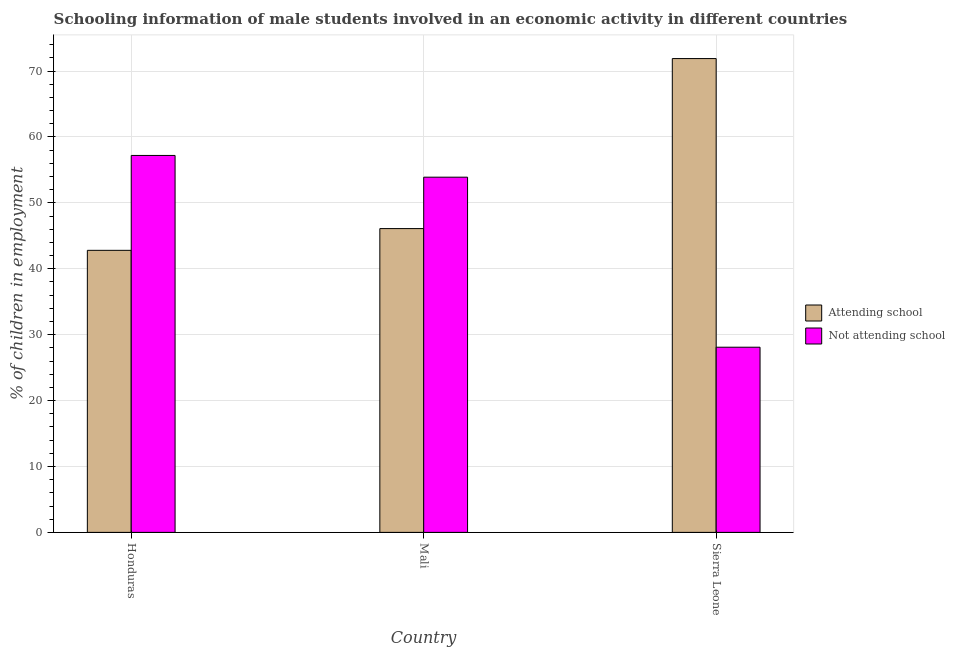Are the number of bars per tick equal to the number of legend labels?
Offer a terse response. Yes. How many bars are there on the 3rd tick from the left?
Offer a terse response. 2. What is the label of the 2nd group of bars from the left?
Provide a short and direct response. Mali. What is the percentage of employed males who are not attending school in Honduras?
Your response must be concise. 57.2. Across all countries, what is the maximum percentage of employed males who are not attending school?
Offer a very short reply. 57.2. Across all countries, what is the minimum percentage of employed males who are not attending school?
Your response must be concise. 28.1. In which country was the percentage of employed males who are attending school maximum?
Offer a very short reply. Sierra Leone. In which country was the percentage of employed males who are not attending school minimum?
Offer a very short reply. Sierra Leone. What is the total percentage of employed males who are not attending school in the graph?
Provide a succinct answer. 139.2. What is the difference between the percentage of employed males who are not attending school in Mali and that in Sierra Leone?
Make the answer very short. 25.8. What is the difference between the percentage of employed males who are attending school in Sierra Leone and the percentage of employed males who are not attending school in Honduras?
Offer a terse response. 14.7. What is the average percentage of employed males who are not attending school per country?
Ensure brevity in your answer.  46.4. What is the difference between the percentage of employed males who are not attending school and percentage of employed males who are attending school in Sierra Leone?
Provide a succinct answer. -43.8. What is the ratio of the percentage of employed males who are attending school in Honduras to that in Mali?
Provide a short and direct response. 0.93. Is the difference between the percentage of employed males who are attending school in Mali and Sierra Leone greater than the difference between the percentage of employed males who are not attending school in Mali and Sierra Leone?
Provide a short and direct response. No. What is the difference between the highest and the second highest percentage of employed males who are attending school?
Provide a succinct answer. 25.8. What is the difference between the highest and the lowest percentage of employed males who are attending school?
Keep it short and to the point. 29.1. Is the sum of the percentage of employed males who are attending school in Honduras and Sierra Leone greater than the maximum percentage of employed males who are not attending school across all countries?
Keep it short and to the point. Yes. What does the 2nd bar from the left in Mali represents?
Keep it short and to the point. Not attending school. What does the 2nd bar from the right in Sierra Leone represents?
Make the answer very short. Attending school. How many bars are there?
Your answer should be compact. 6. What is the difference between two consecutive major ticks on the Y-axis?
Offer a terse response. 10. Are the values on the major ticks of Y-axis written in scientific E-notation?
Make the answer very short. No. Does the graph contain any zero values?
Keep it short and to the point. No. Where does the legend appear in the graph?
Your response must be concise. Center right. How many legend labels are there?
Keep it short and to the point. 2. How are the legend labels stacked?
Make the answer very short. Vertical. What is the title of the graph?
Your answer should be compact. Schooling information of male students involved in an economic activity in different countries. Does "Female labourers" appear as one of the legend labels in the graph?
Your answer should be very brief. No. What is the label or title of the Y-axis?
Give a very brief answer. % of children in employment. What is the % of children in employment of Attending school in Honduras?
Provide a short and direct response. 42.8. What is the % of children in employment of Not attending school in Honduras?
Ensure brevity in your answer.  57.2. What is the % of children in employment of Attending school in Mali?
Provide a short and direct response. 46.1. What is the % of children in employment of Not attending school in Mali?
Provide a short and direct response. 53.9. What is the % of children in employment in Attending school in Sierra Leone?
Ensure brevity in your answer.  71.9. What is the % of children in employment in Not attending school in Sierra Leone?
Your response must be concise. 28.1. Across all countries, what is the maximum % of children in employment in Attending school?
Your answer should be very brief. 71.9. Across all countries, what is the maximum % of children in employment of Not attending school?
Your response must be concise. 57.2. Across all countries, what is the minimum % of children in employment of Attending school?
Your response must be concise. 42.8. Across all countries, what is the minimum % of children in employment of Not attending school?
Provide a short and direct response. 28.1. What is the total % of children in employment of Attending school in the graph?
Ensure brevity in your answer.  160.8. What is the total % of children in employment in Not attending school in the graph?
Your answer should be very brief. 139.2. What is the difference between the % of children in employment of Not attending school in Honduras and that in Mali?
Give a very brief answer. 3.3. What is the difference between the % of children in employment in Attending school in Honduras and that in Sierra Leone?
Provide a succinct answer. -29.1. What is the difference between the % of children in employment in Not attending school in Honduras and that in Sierra Leone?
Your response must be concise. 29.1. What is the difference between the % of children in employment in Attending school in Mali and that in Sierra Leone?
Provide a short and direct response. -25.8. What is the difference between the % of children in employment of Not attending school in Mali and that in Sierra Leone?
Ensure brevity in your answer.  25.8. What is the average % of children in employment in Attending school per country?
Offer a terse response. 53.6. What is the average % of children in employment of Not attending school per country?
Your answer should be compact. 46.4. What is the difference between the % of children in employment of Attending school and % of children in employment of Not attending school in Honduras?
Offer a very short reply. -14.4. What is the difference between the % of children in employment in Attending school and % of children in employment in Not attending school in Sierra Leone?
Make the answer very short. 43.8. What is the ratio of the % of children in employment of Attending school in Honduras to that in Mali?
Keep it short and to the point. 0.93. What is the ratio of the % of children in employment in Not attending school in Honduras to that in Mali?
Provide a short and direct response. 1.06. What is the ratio of the % of children in employment of Attending school in Honduras to that in Sierra Leone?
Your response must be concise. 0.6. What is the ratio of the % of children in employment in Not attending school in Honduras to that in Sierra Leone?
Your response must be concise. 2.04. What is the ratio of the % of children in employment of Attending school in Mali to that in Sierra Leone?
Make the answer very short. 0.64. What is the ratio of the % of children in employment of Not attending school in Mali to that in Sierra Leone?
Offer a terse response. 1.92. What is the difference between the highest and the second highest % of children in employment in Attending school?
Offer a terse response. 25.8. What is the difference between the highest and the second highest % of children in employment of Not attending school?
Your response must be concise. 3.3. What is the difference between the highest and the lowest % of children in employment in Attending school?
Your answer should be very brief. 29.1. What is the difference between the highest and the lowest % of children in employment of Not attending school?
Make the answer very short. 29.1. 